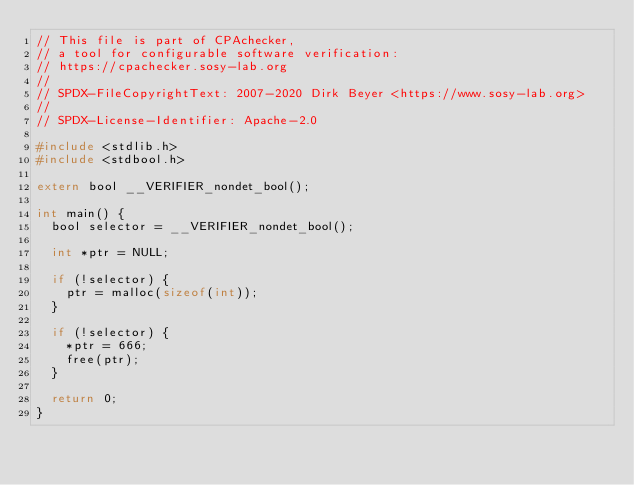Convert code to text. <code><loc_0><loc_0><loc_500><loc_500><_C_>// This file is part of CPAchecker,
// a tool for configurable software verification:
// https://cpachecker.sosy-lab.org
//
// SPDX-FileCopyrightText: 2007-2020 Dirk Beyer <https://www.sosy-lab.org>
//
// SPDX-License-Identifier: Apache-2.0

#include <stdlib.h>
#include <stdbool.h>

extern bool __VERIFIER_nondet_bool();

int main() {
  bool selector = __VERIFIER_nondet_bool();

  int *ptr = NULL;

  if (!selector) {
    ptr = malloc(sizeof(int));
  }

  if (!selector) {
    *ptr = 666;
    free(ptr);
  }

  return 0;
}
</code> 